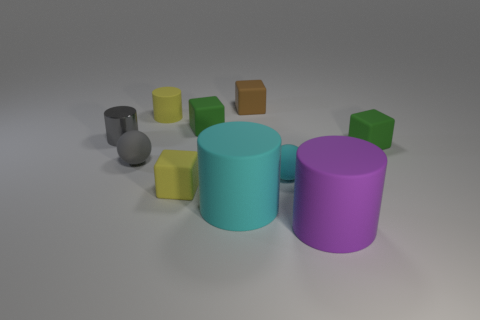Subtract all purple cylinders. How many cylinders are left? 3 Subtract all purple cylinders. How many cylinders are left? 3 Subtract 4 cubes. How many cubes are left? 0 Subtract all red spheres. How many green blocks are left? 2 Subtract 1 yellow cylinders. How many objects are left? 9 Subtract all balls. How many objects are left? 8 Subtract all green cubes. Subtract all green cylinders. How many cubes are left? 2 Subtract all tiny metal cylinders. Subtract all tiny balls. How many objects are left? 7 Add 1 gray rubber spheres. How many gray rubber spheres are left? 2 Add 10 big gray metal spheres. How many big gray metal spheres exist? 10 